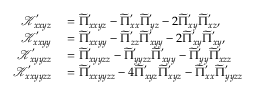Convert formula to latex. <formula><loc_0><loc_0><loc_500><loc_500>\begin{array} { r l } { \mathcal { K } _ { x x y z } ^ { ^ { \prime } } } & = \widetilde { \Pi } _ { x x y z } ^ { ^ { \prime } } - \widetilde { \Pi } _ { x x } ^ { ^ { \prime } } \widetilde { \Pi } _ { y z } ^ { ^ { \prime } } - 2 \widetilde { \Pi } _ { x y } ^ { ^ { \prime } } \widetilde { \Pi } _ { x z } ^ { ^ { \prime } } , } \\ { \mathcal { K } _ { x x y y } ^ { ^ { \prime } } } & = \widetilde { \Pi } _ { x x y y } ^ { ^ { \prime } } - \widetilde { \Pi } _ { z z } ^ { ^ { \prime } } \widetilde { \Pi } _ { x y y } ^ { ^ { \prime } } - 2 \widetilde { \Pi } _ { x y } ^ { ^ { \prime } } \widetilde { \Pi } _ { x y } ^ { ^ { \prime } } , } \\ { \mathcal { K } _ { x y y z z } ^ { ^ { \prime } } } & = \widetilde { \Pi } _ { x y y z z } ^ { ^ { \prime } } - \widetilde { \Pi } _ { y y z z } ^ { ^ { \prime } } \widetilde { \Pi } _ { x y y } ^ { ^ { \prime } } - \widetilde { \Pi } _ { y y } ^ { ^ { \prime } } \widetilde { \Pi } _ { x z z } ^ { ^ { \prime } } } \\ { \mathcal { K } _ { x x y y z z } ^ { ^ { \prime } } } & = \widetilde { \Pi } _ { x x y y z z } ^ { ^ { \prime } } - 4 \widetilde { \Pi } _ { x y z } ^ { ^ { \prime } } \widetilde { \Pi } _ { x y z } ^ { ^ { \prime } } - \widetilde { \Pi } _ { x x } ^ { ^ { \prime } } \widetilde { \Pi } _ { y y z z } ^ { ^ { \prime } } } \end{array}</formula> 